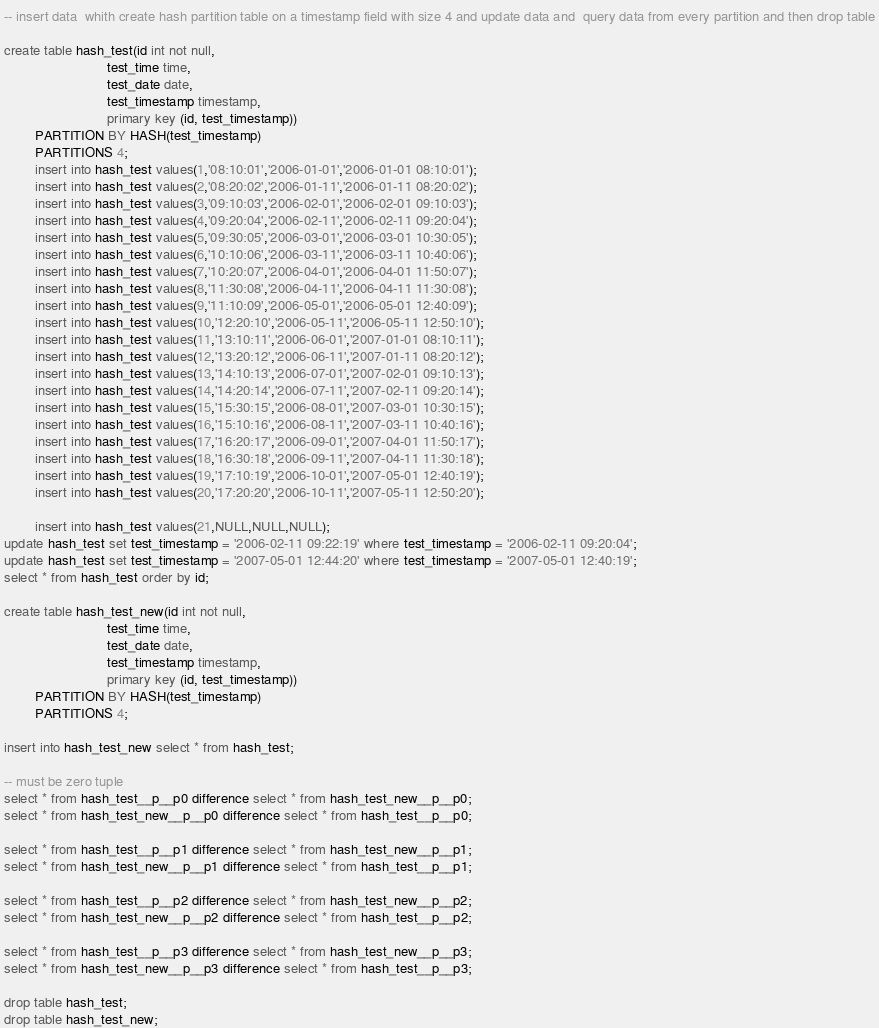Convert code to text. <code><loc_0><loc_0><loc_500><loc_500><_SQL_>-- insert data  whith create hash partition table on a timestamp field with size 4 and update data and  query data from every partition and then drop table

create table hash_test(id int not null,     
                           test_time time,
                           test_date date,
                           test_timestamp timestamp,
                           primary key (id, test_timestamp))
        PARTITION BY HASH(test_timestamp)
        PARTITIONS 4;
        insert into hash_test values(1,'08:10:01','2006-01-01','2006-01-01 08:10:01');
        insert into hash_test values(2,'08:20:02','2006-01-11','2006-01-11 08:20:02');
        insert into hash_test values(3,'09:10:03','2006-02-01','2006-02-01 09:10:03');
        insert into hash_test values(4,'09:20:04','2006-02-11','2006-02-11 09:20:04');
        insert into hash_test values(5,'09:30:05','2006-03-01','2006-03-01 10:30:05');
        insert into hash_test values(6,'10:10:06','2006-03-11','2006-03-11 10:40:06');
        insert into hash_test values(7,'10:20:07','2006-04-01','2006-04-01 11:50:07');
        insert into hash_test values(8,'11:30:08','2006-04-11','2006-04-11 11:30:08');
        insert into hash_test values(9,'11:10:09','2006-05-01','2006-05-01 12:40:09');
        insert into hash_test values(10,'12:20:10','2006-05-11','2006-05-11 12:50:10');
        insert into hash_test values(11,'13:10:11','2006-06-01','2007-01-01 08:10:11');
        insert into hash_test values(12,'13:20:12','2006-06-11','2007-01-11 08:20:12');
        insert into hash_test values(13,'14:10:13','2006-07-01','2007-02-01 09:10:13');
        insert into hash_test values(14,'14:20:14','2006-07-11','2007-02-11 09:20:14');
        insert into hash_test values(15,'15:30:15','2006-08-01','2007-03-01 10:30:15');
        insert into hash_test values(16,'15:10:16','2006-08-11','2007-03-11 10:40:16');
        insert into hash_test values(17,'16:20:17','2006-09-01','2007-04-01 11:50:17');
        insert into hash_test values(18,'16:30:18','2006-09-11','2007-04-11 11:30:18');
        insert into hash_test values(19,'17:10:19','2006-10-01','2007-05-01 12:40:19');
        insert into hash_test values(20,'17:20:20','2006-10-11','2007-05-11 12:50:20');

        insert into hash_test values(21,NULL,NULL,NULL);
update hash_test set test_timestamp = '2006-02-11 09:22:19' where test_timestamp = '2006-02-11 09:20:04';
update hash_test set test_timestamp = '2007-05-01 12:44:20' where test_timestamp = '2007-05-01 12:40:19';
select * from hash_test order by id;

create table hash_test_new(id int not null,
                           test_time time,
                           test_date date,
                           test_timestamp timestamp,
                           primary key (id, test_timestamp))
        PARTITION BY HASH(test_timestamp)
        PARTITIONS 4;

insert into hash_test_new select * from hash_test;

-- must be zero tuple  
select * from hash_test__p__p0 difference select * from hash_test_new__p__p0;
select * from hash_test_new__p__p0 difference select * from hash_test__p__p0;

select * from hash_test__p__p1 difference select * from hash_test_new__p__p1;
select * from hash_test_new__p__p1 difference select * from hash_test__p__p1;

select * from hash_test__p__p2 difference select * from hash_test_new__p__p2;
select * from hash_test_new__p__p2 difference select * from hash_test__p__p2;

select * from hash_test__p__p3 difference select * from hash_test_new__p__p3;
select * from hash_test_new__p__p3 difference select * from hash_test__p__p3;

drop table hash_test;
drop table hash_test_new;

</code> 